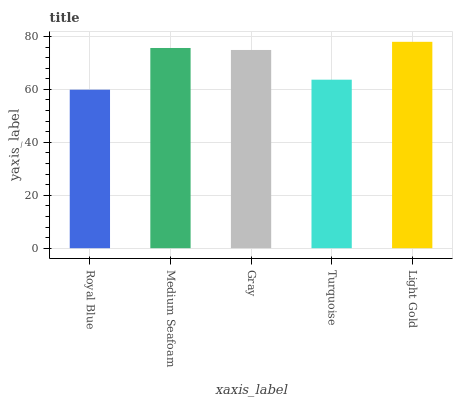Is Medium Seafoam the minimum?
Answer yes or no. No. Is Medium Seafoam the maximum?
Answer yes or no. No. Is Medium Seafoam greater than Royal Blue?
Answer yes or no. Yes. Is Royal Blue less than Medium Seafoam?
Answer yes or no. Yes. Is Royal Blue greater than Medium Seafoam?
Answer yes or no. No. Is Medium Seafoam less than Royal Blue?
Answer yes or no. No. Is Gray the high median?
Answer yes or no. Yes. Is Gray the low median?
Answer yes or no. Yes. Is Light Gold the high median?
Answer yes or no. No. Is Royal Blue the low median?
Answer yes or no. No. 